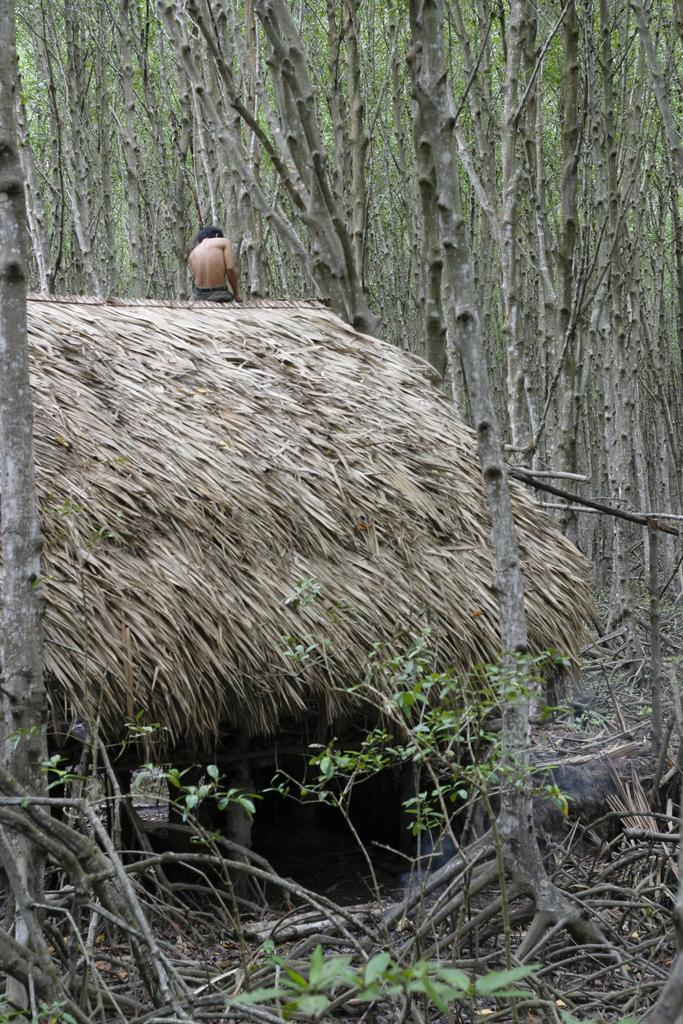What types of natural elements are present in the image? There are plants and sticks in the image. What type of structure can be seen in the image? There is a hut in the image. Are there any people in the image? Yes, there is a person in the image. What can be seen in the background of the image? There are trees in the background of the image. How many cats are sitting on the roof of the hut in the image? There are no cats present in the image; it only features plants, sticks, a hut, and a person. 